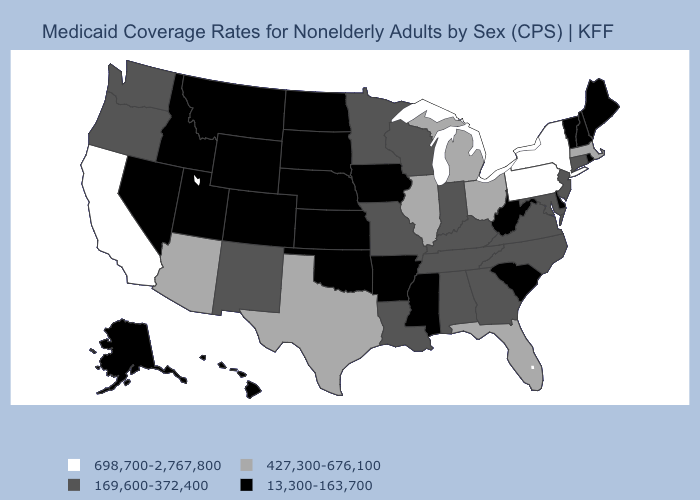What is the value of Utah?
Concise answer only. 13,300-163,700. What is the value of Florida?
Answer briefly. 427,300-676,100. Does Idaho have a lower value than Vermont?
Answer briefly. No. Name the states that have a value in the range 169,600-372,400?
Give a very brief answer. Alabama, Connecticut, Georgia, Indiana, Kentucky, Louisiana, Maryland, Minnesota, Missouri, New Jersey, New Mexico, North Carolina, Oregon, Tennessee, Virginia, Washington, Wisconsin. Name the states that have a value in the range 169,600-372,400?
Be succinct. Alabama, Connecticut, Georgia, Indiana, Kentucky, Louisiana, Maryland, Minnesota, Missouri, New Jersey, New Mexico, North Carolina, Oregon, Tennessee, Virginia, Washington, Wisconsin. Name the states that have a value in the range 427,300-676,100?
Give a very brief answer. Arizona, Florida, Illinois, Massachusetts, Michigan, Ohio, Texas. Which states have the lowest value in the USA?
Write a very short answer. Alaska, Arkansas, Colorado, Delaware, Hawaii, Idaho, Iowa, Kansas, Maine, Mississippi, Montana, Nebraska, Nevada, New Hampshire, North Dakota, Oklahoma, Rhode Island, South Carolina, South Dakota, Utah, Vermont, West Virginia, Wyoming. Which states have the highest value in the USA?
Quick response, please. California, New York, Pennsylvania. Among the states that border California , which have the highest value?
Answer briefly. Arizona. What is the lowest value in the South?
Concise answer only. 13,300-163,700. What is the value of New York?
Write a very short answer. 698,700-2,767,800. Name the states that have a value in the range 169,600-372,400?
Keep it brief. Alabama, Connecticut, Georgia, Indiana, Kentucky, Louisiana, Maryland, Minnesota, Missouri, New Jersey, New Mexico, North Carolina, Oregon, Tennessee, Virginia, Washington, Wisconsin. What is the value of Kentucky?
Short answer required. 169,600-372,400. Does the map have missing data?
Quick response, please. No. What is the lowest value in states that border New York?
Give a very brief answer. 13,300-163,700. 